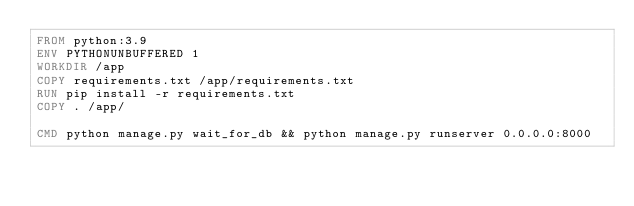Convert code to text. <code><loc_0><loc_0><loc_500><loc_500><_Dockerfile_>FROM python:3.9
ENV PYTHONUNBUFFERED 1
WORKDIR /app
COPY requirements.txt /app/requirements.txt
RUN pip install -r requirements.txt
COPY . /app/

CMD python manage.py wait_for_db && python manage.py runserver 0.0.0.0:8000</code> 